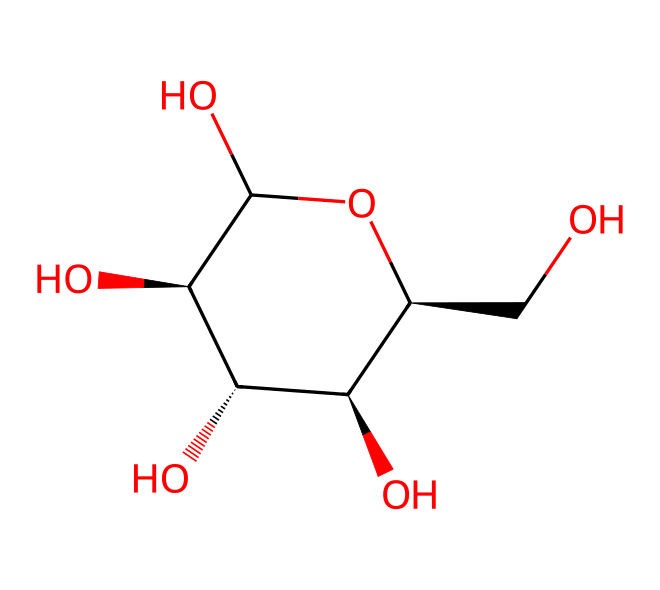What is the molecular formula of glucose? To determine the molecular formula, count the number of carbon (C), hydrogen (H), and oxygen (O) atoms from the structure. In this case, there are 6 carbon atoms, 12 hydrogen atoms, and 6 oxygen atoms, leading to the formula C6H12O6.
Answer: C6H12O6 How many hydroxyl (-OH) groups are present in glucose? The structure shows that glucose has 5 hydroxyl groups. Each -OH group contributes to the functionality of glucose as an alcohol.
Answer: 5 What type of carbohydrate is glucose? Glucose is classified as a monosaccharide, which is the simplest form of carbohydrates and cannot be hydrolyzed into simpler sugars.
Answer: monosaccharide What is the stereochemistry of the primary alcohol in glucose? The primary alcohol in glucose is at the C1 carbon, which has a specific orientation indicated by the stereochemical configuration shown in the SMILES representation. The notation indicates it is in the D-configuration.
Answer: D-configuration How many chiral centers are present in glucose? Chiral centers are carbon atoms that have four different substituents. In glucose, there are 4 chiral centers at carbons C2, C3, C4, and C5, which allows for stereoisomerism.
Answer: 4 What is the role of glucose in living organisms? Glucose primarily serves as an energy source for cells. It is fundamental in cellular respiration, providing ATP through metabolic pathways.
Answer: energy source 